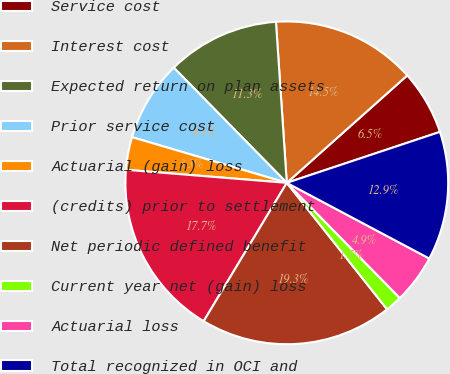Convert chart. <chart><loc_0><loc_0><loc_500><loc_500><pie_chart><fcel>Service cost<fcel>Interest cost<fcel>Expected return on plan assets<fcel>Prior service cost<fcel>Actuarial (gain) loss<fcel>(credits) prior to settlement<fcel>Net periodic defined benefit<fcel>Current year net (gain) loss<fcel>Actuarial loss<fcel>Total recognized in OCI and<nl><fcel>6.48%<fcel>14.48%<fcel>11.28%<fcel>8.08%<fcel>3.28%<fcel>17.68%<fcel>19.28%<fcel>1.68%<fcel>4.88%<fcel>12.88%<nl></chart> 